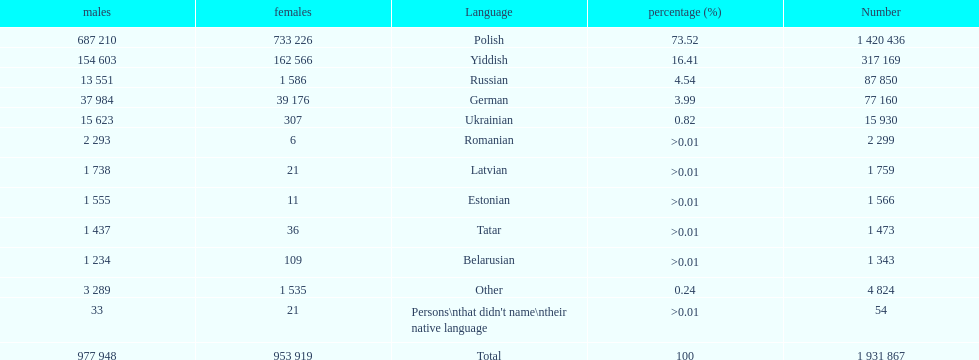What named native languages spoken in the warsaw governorate have more males then females? Russian, Ukrainian, Romanian, Latvian, Estonian, Tatar, Belarusian. Which of those have less then 500 males listed? Romanian, Latvian, Estonian, Tatar, Belarusian. Of the remaining languages which of them have less then 20 females? Romanian, Estonian. Which of these has the highest total number listed? Romanian. 